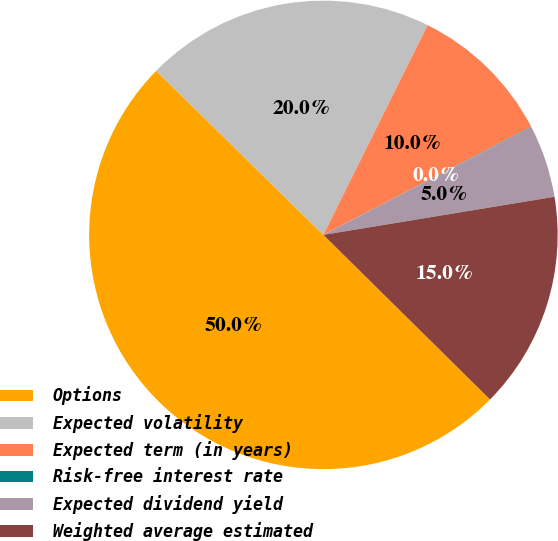Convert chart. <chart><loc_0><loc_0><loc_500><loc_500><pie_chart><fcel>Options<fcel>Expected volatility<fcel>Expected term (in years)<fcel>Risk-free interest rate<fcel>Expected dividend yield<fcel>Weighted average estimated<nl><fcel>49.95%<fcel>19.99%<fcel>10.01%<fcel>0.03%<fcel>5.02%<fcel>15.0%<nl></chart> 